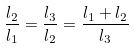<formula> <loc_0><loc_0><loc_500><loc_500>\frac { l _ { 2 } } { l _ { 1 } } = \frac { l _ { 3 } } { l _ { 2 } } = \frac { l _ { 1 } + l _ { 2 } } { l _ { 3 } }</formula> 